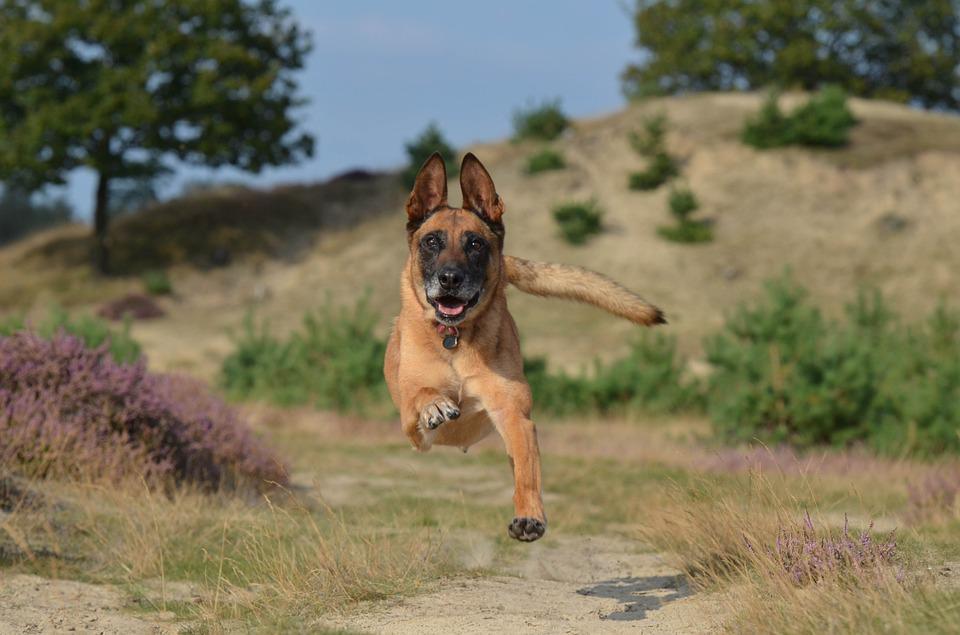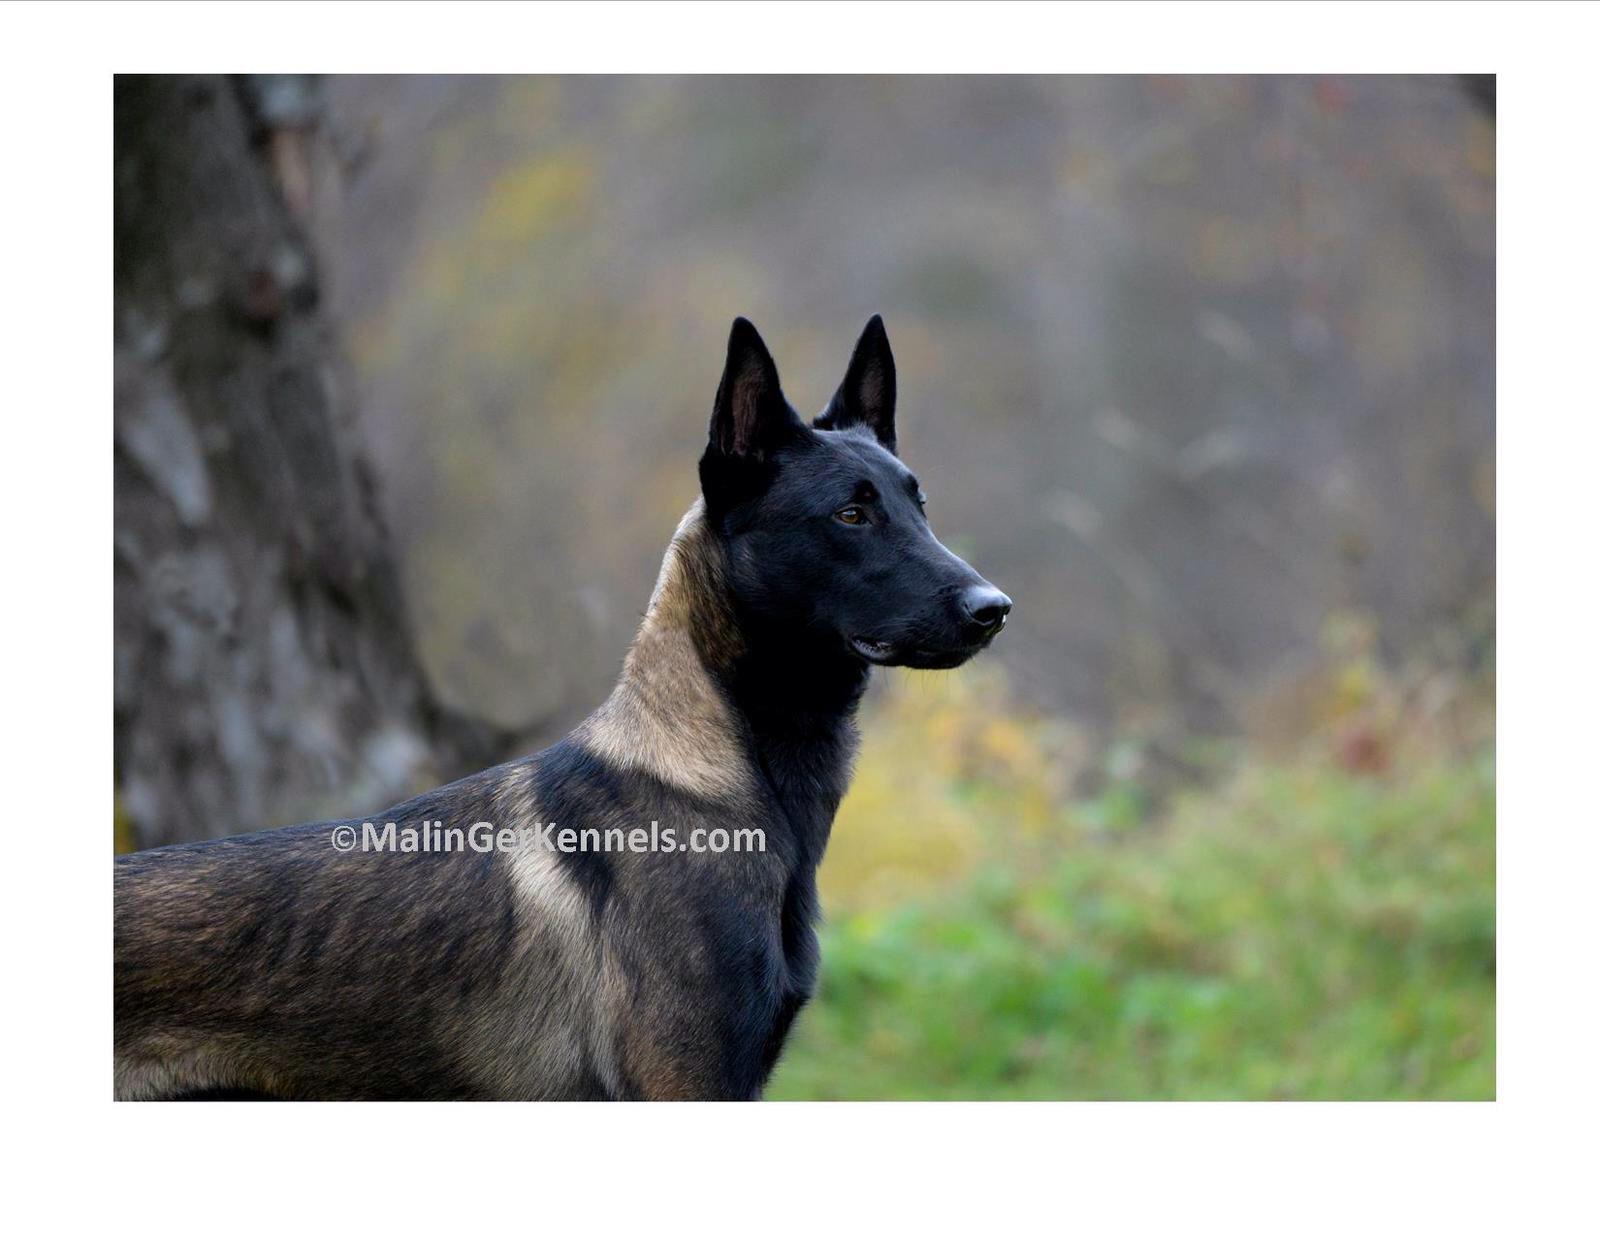The first image is the image on the left, the second image is the image on the right. For the images shown, is this caption "An image shows a dog running toward the camera and facing forward." true? Answer yes or no. Yes. The first image is the image on the left, the second image is the image on the right. Analyze the images presented: Is the assertion "At least one dog is running toward the camera." valid? Answer yes or no. Yes. 